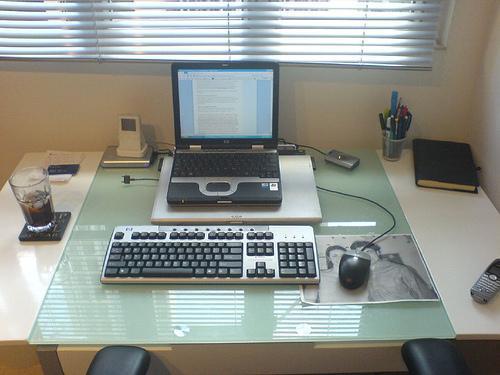How many people are wearing a pink shirt?
Give a very brief answer. 0. 